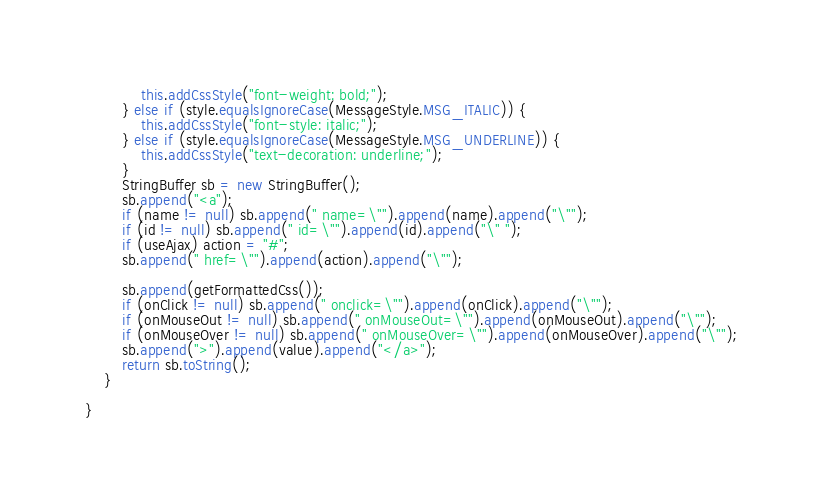Convert code to text. <code><loc_0><loc_0><loc_500><loc_500><_Java_>            this.addCssStyle("font-weight: bold;");
        } else if (style.equalsIgnoreCase(MessageStyle.MSG_ITALIC)) {
            this.addCssStyle("font-style: italic;");
        } else if (style.equalsIgnoreCase(MessageStyle.MSG_UNDERLINE)) {
            this.addCssStyle("text-decoration: underline;");
        }
        StringBuffer sb = new StringBuffer();
        sb.append("<a");
        if (name != null) sb.append(" name=\"").append(name).append("\"");
        if (id != null) sb.append(" id=\"").append(id).append("\" ");
        if (useAjax) action = "#";
        sb.append(" href=\"").append(action).append("\"");

        sb.append(getFormattedCss());
        if (onClick != null) sb.append(" onclick=\"").append(onClick).append("\"");
        if (onMouseOut != null) sb.append(" onMouseOut=\"").append(onMouseOut).append("\"");
        if (onMouseOver != null) sb.append(" onMouseOver=\"").append(onMouseOver).append("\"");
        sb.append(">").append(value).append("</a>");
        return sb.toString();
    }

}
</code> 